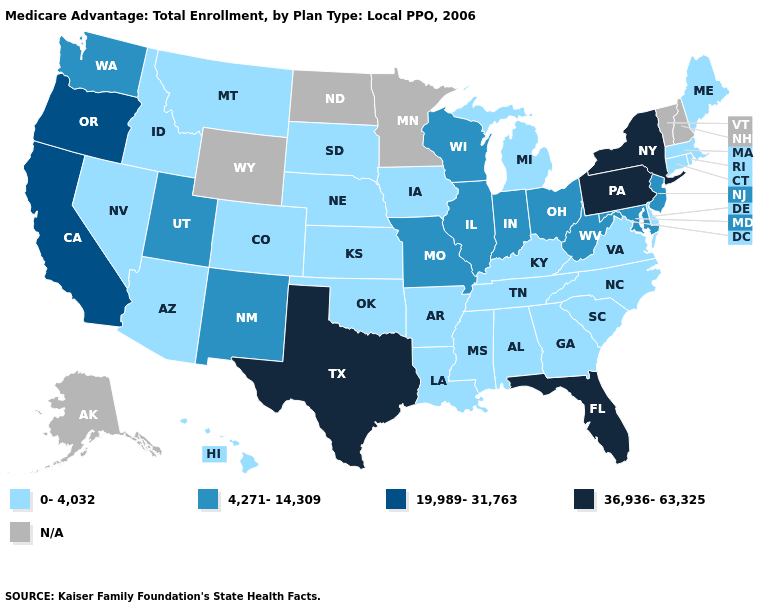Name the states that have a value in the range 4,271-14,309?
Answer briefly. Illinois, Indiana, Maryland, Missouri, New Jersey, New Mexico, Ohio, Utah, Washington, Wisconsin, West Virginia. Name the states that have a value in the range 4,271-14,309?
Keep it brief. Illinois, Indiana, Maryland, Missouri, New Jersey, New Mexico, Ohio, Utah, Washington, Wisconsin, West Virginia. Name the states that have a value in the range 4,271-14,309?
Give a very brief answer. Illinois, Indiana, Maryland, Missouri, New Jersey, New Mexico, Ohio, Utah, Washington, Wisconsin, West Virginia. What is the value of Nebraska?
Keep it brief. 0-4,032. How many symbols are there in the legend?
Quick response, please. 5. What is the value of Hawaii?
Write a very short answer. 0-4,032. What is the value of Oregon?
Keep it brief. 19,989-31,763. What is the highest value in the USA?
Concise answer only. 36,936-63,325. Does Illinois have the lowest value in the USA?
Give a very brief answer. No. What is the value of Idaho?
Give a very brief answer. 0-4,032. Name the states that have a value in the range 0-4,032?
Short answer required. Alabama, Arkansas, Arizona, Colorado, Connecticut, Delaware, Georgia, Hawaii, Iowa, Idaho, Kansas, Kentucky, Louisiana, Massachusetts, Maine, Michigan, Mississippi, Montana, North Carolina, Nebraska, Nevada, Oklahoma, Rhode Island, South Carolina, South Dakota, Tennessee, Virginia. Name the states that have a value in the range 19,989-31,763?
Write a very short answer. California, Oregon. What is the lowest value in states that border Idaho?
Write a very short answer. 0-4,032. Which states have the highest value in the USA?
Quick response, please. Florida, New York, Pennsylvania, Texas. 